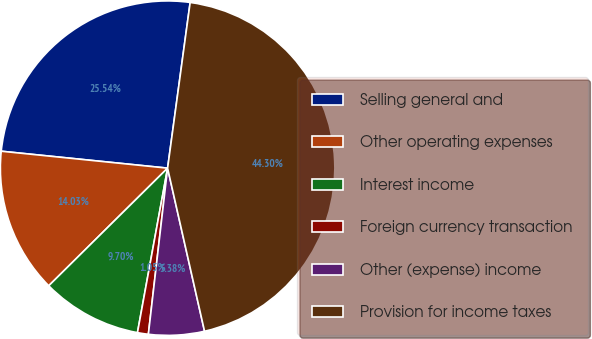<chart> <loc_0><loc_0><loc_500><loc_500><pie_chart><fcel>Selling general and<fcel>Other operating expenses<fcel>Interest income<fcel>Foreign currency transaction<fcel>Other (expense) income<fcel>Provision for income taxes<nl><fcel>25.54%<fcel>14.03%<fcel>9.7%<fcel>1.05%<fcel>5.38%<fcel>44.3%<nl></chart> 